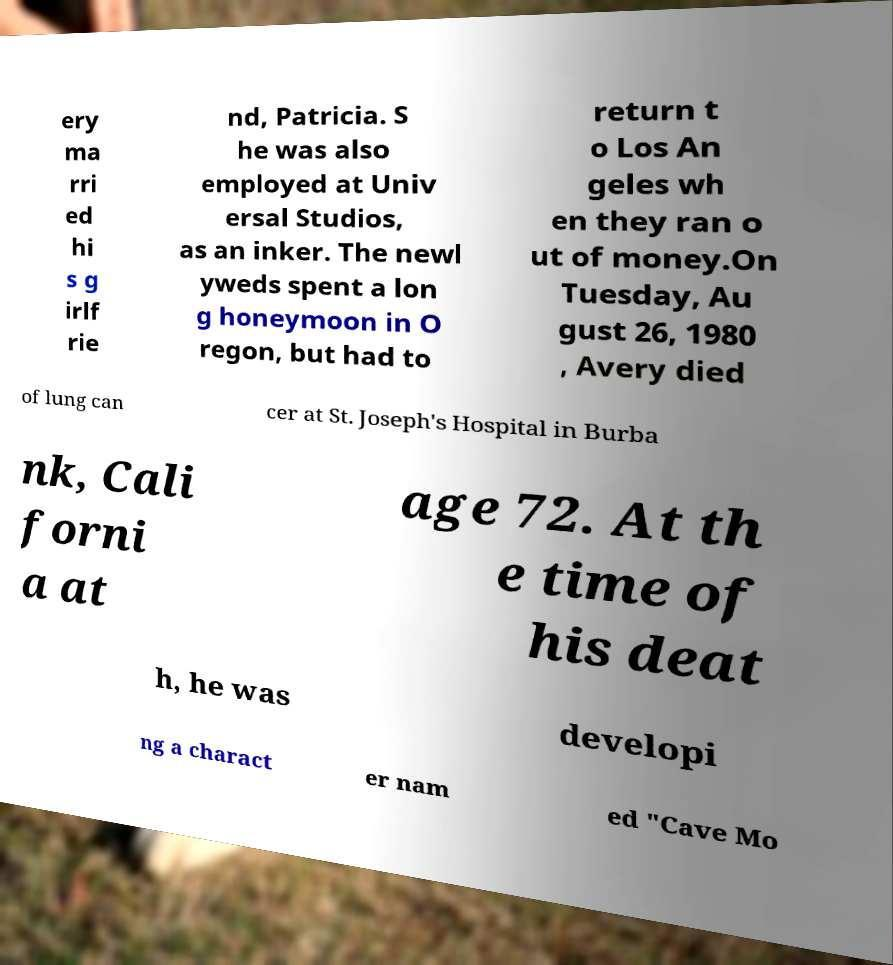Please read and relay the text visible in this image. What does it say? ery ma rri ed hi s g irlf rie nd, Patricia. S he was also employed at Univ ersal Studios, as an inker. The newl yweds spent a lon g honeymoon in O regon, but had to return t o Los An geles wh en they ran o ut of money.On Tuesday, Au gust 26, 1980 , Avery died of lung can cer at St. Joseph's Hospital in Burba nk, Cali forni a at age 72. At th e time of his deat h, he was developi ng a charact er nam ed "Cave Mo 